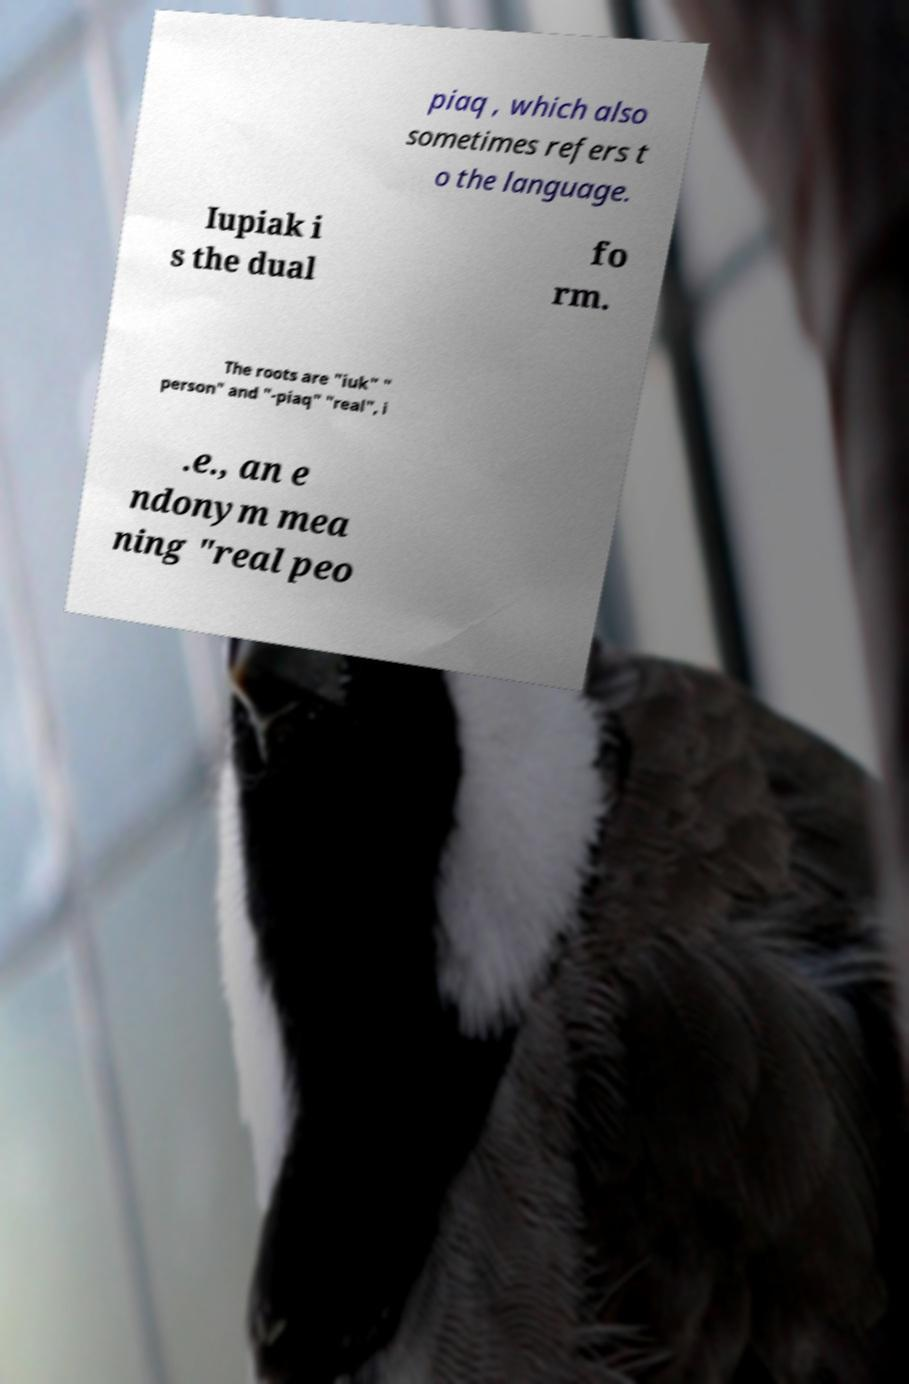Please identify and transcribe the text found in this image. piaq , which also sometimes refers t o the language. Iupiak i s the dual fo rm. The roots are "iuk" " person" and "-piaq" "real", i .e., an e ndonym mea ning "real peo 